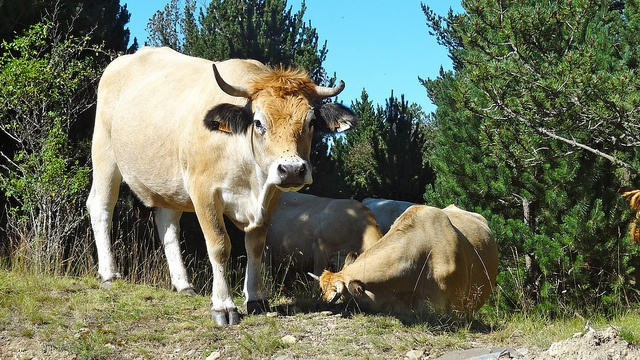Describe the objects in this image and their specific colors. I can see cow in black, beige, tan, and gray tones, cow in black, tan, and darkgreen tones, cow in black and purple tones, and cow in black, blue, and darkblue tones in this image. 